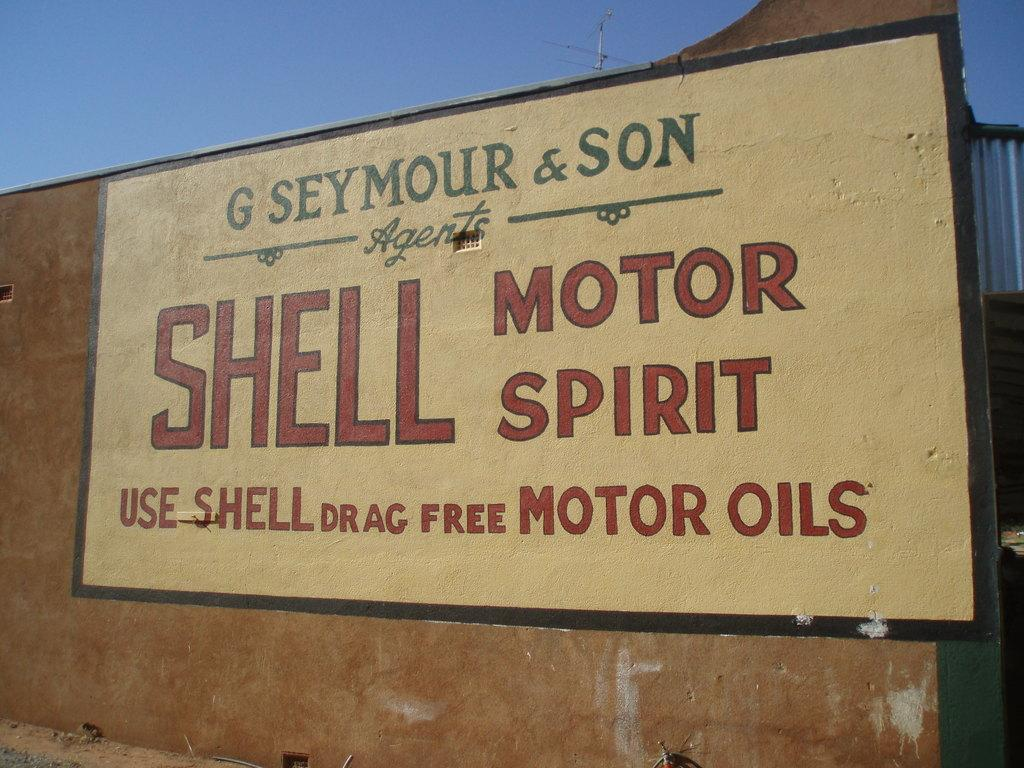<image>
Give a short and clear explanation of the subsequent image. A large outdoor sign with Shell Motor Spirit on it. 